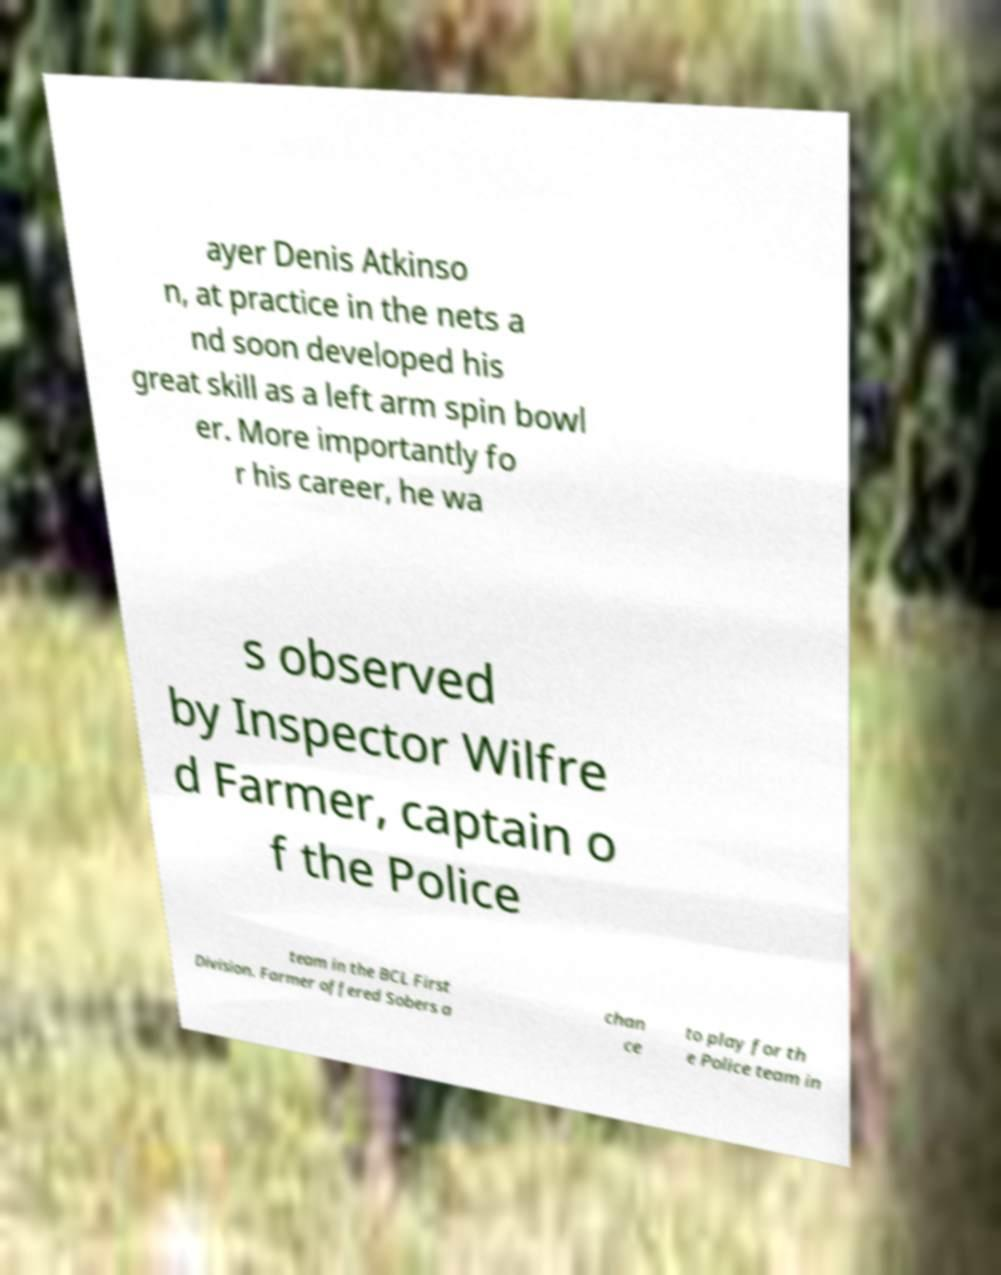Could you assist in decoding the text presented in this image and type it out clearly? ayer Denis Atkinso n, at practice in the nets a nd soon developed his great skill as a left arm spin bowl er. More importantly fo r his career, he wa s observed by Inspector Wilfre d Farmer, captain o f the Police team in the BCL First Division. Farmer offered Sobers a chan ce to play for th e Police team in 